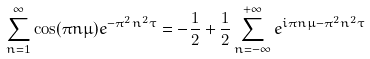<formula> <loc_0><loc_0><loc_500><loc_500>\sum _ { n = 1 } ^ { \infty } \cos ( \pi n \mu ) e ^ { - \pi ^ { 2 } n ^ { 2 } \tau } = - \frac { 1 } { 2 } + \frac { 1 } { 2 } \sum _ { n = - \infty } ^ { + \infty } e ^ { i \pi n \mu - \pi ^ { 2 } n ^ { 2 } \tau }</formula> 